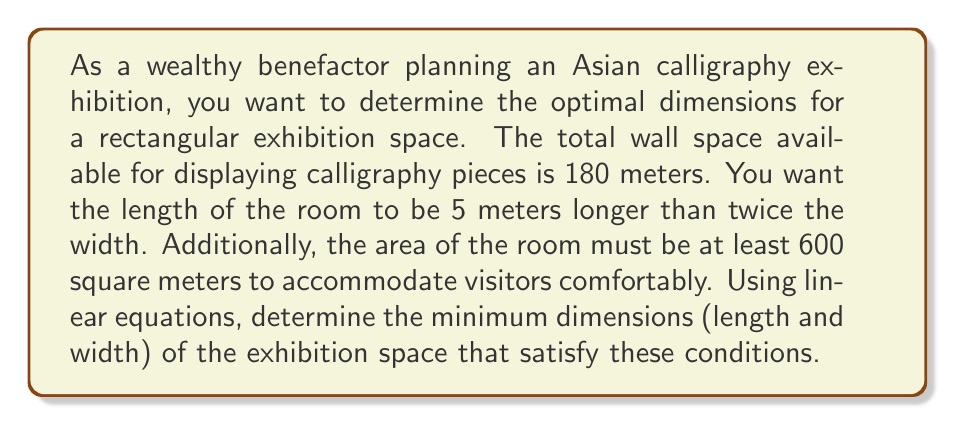Can you answer this question? Let's approach this problem step-by-step using linear equations:

1) Let $w$ be the width of the room and $l$ be the length.

2) Given that the total wall space is 180 meters, we can write:
   $$ 2w + 2l = 180 $$

3) We're told that the length should be 5 meters longer than twice the width:
   $$ l = 2w + 5 $$

4) Substituting this into our first equation:
   $$ 2w + 2(2w + 5) = 180 $$
   $$ 2w + 4w + 10 = 180 $$
   $$ 6w + 10 = 180 $$
   $$ 6w = 170 $$
   $$ w = \frac{170}{6} \approx 28.33 $$

5) Now we can calculate $l$:
   $$ l = 2(28.33) + 5 = 61.66 $$

6) Let's check if this satisfies the area condition:
   $$ \text{Area} = w \times l = 28.33 \times 61.66 \approx 1747 \text{ sq meters} $$
   This is indeed greater than 600 sq meters.

7) However, we need to find the minimum dimensions. Let's set up an inequality for the area:
   $$ w \times l \geq 600 $$
   $$ w \times (2w + 5) \geq 600 $$
   $$ 2w^2 + 5w - 600 \geq 0 $$

8) Solving this quadratic inequality:
   $$ w \geq \frac{-5 + \sqrt{25 + 4800}}{4} \approx 16.83 $$

9) The minimum width that satisfies all conditions is therefore 16.83 meters.

10) The corresponding length would be:
    $$ l = 2(16.83) + 5 = 38.66 \text{ meters} $$

11) We should round up to ensure we meet all conditions:
    Width = 17 meters, Length = 39 meters
Answer: The minimum dimensions for the exhibition space are approximately 17 meters in width and 39 meters in length. 